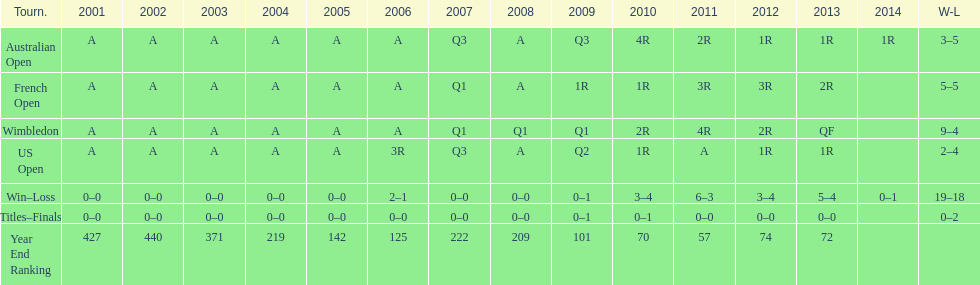What is the difference in wins between wimbledon and the us open for this player? 7. 